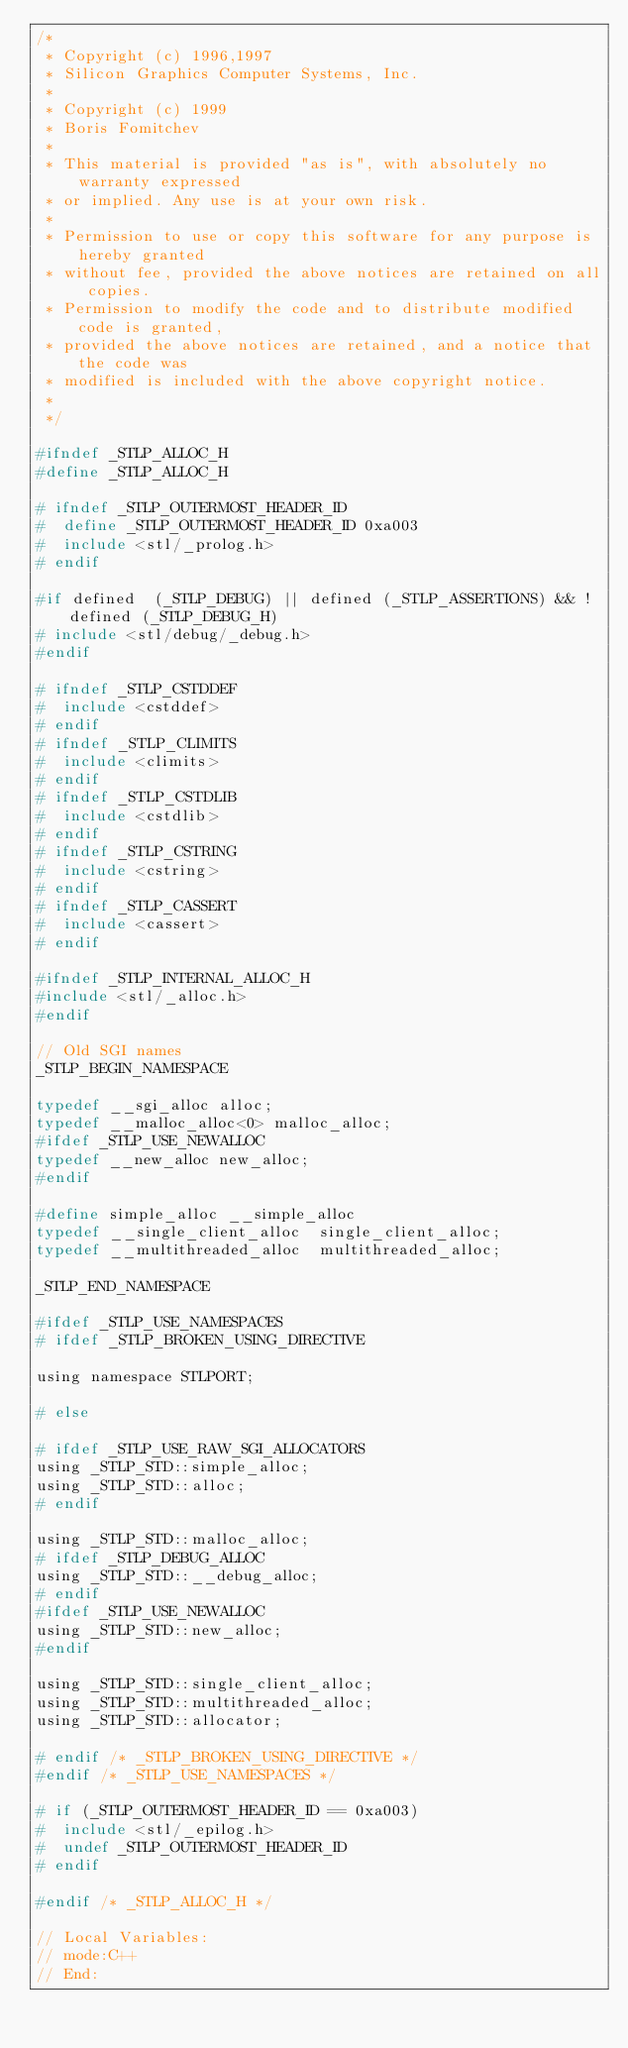<code> <loc_0><loc_0><loc_500><loc_500><_C_>/*
 * Copyright (c) 1996,1997
 * Silicon Graphics Computer Systems, Inc.
 *
 * Copyright (c) 1999 
 * Boris Fomitchev
 *
 * This material is provided "as is", with absolutely no warranty expressed
 * or implied. Any use is at your own risk.
 *
 * Permission to use or copy this software for any purpose is hereby granted 
 * without fee, provided the above notices are retained on all copies.
 * Permission to modify the code and to distribute modified code is granted,
 * provided the above notices are retained, and a notice that the code was
 * modified is included with the above copyright notice.
 *
 */

#ifndef _STLP_ALLOC_H
#define _STLP_ALLOC_H

# ifndef _STLP_OUTERMOST_HEADER_ID
#  define _STLP_OUTERMOST_HEADER_ID 0xa003
#  include <stl/_prolog.h>
# endif

#if defined  (_STLP_DEBUG) || defined (_STLP_ASSERTIONS) && !defined (_STLP_DEBUG_H)
# include <stl/debug/_debug.h>
#endif

# ifndef _STLP_CSTDDEF
#  include <cstddef>
# endif
# ifndef _STLP_CLIMITS
#  include <climits>
# endif
# ifndef _STLP_CSTDLIB
#  include <cstdlib>
# endif
# ifndef _STLP_CSTRING
#  include <cstring>
# endif
# ifndef _STLP_CASSERT
#  include <cassert>
# endif

#ifndef _STLP_INTERNAL_ALLOC_H
#include <stl/_alloc.h>
#endif

// Old SGI names
_STLP_BEGIN_NAMESPACE

typedef __sgi_alloc alloc;
typedef __malloc_alloc<0> malloc_alloc;
#ifdef _STLP_USE_NEWALLOC
typedef __new_alloc new_alloc;
#endif

#define simple_alloc __simple_alloc
typedef __single_client_alloc  single_client_alloc; 
typedef __multithreaded_alloc  multithreaded_alloc; 

_STLP_END_NAMESPACE

#ifdef _STLP_USE_NAMESPACES
# ifdef _STLP_BROKEN_USING_DIRECTIVE

using namespace STLPORT;

# else

# ifdef _STLP_USE_RAW_SGI_ALLOCATORS
using _STLP_STD::simple_alloc;
using _STLP_STD::alloc;
# endif

using _STLP_STD::malloc_alloc; 
# ifdef _STLP_DEBUG_ALLOC
using _STLP_STD::__debug_alloc;
# endif 
#ifdef _STLP_USE_NEWALLOC
using _STLP_STD::new_alloc;
#endif

using _STLP_STD::single_client_alloc; 
using _STLP_STD::multithreaded_alloc; 
using _STLP_STD::allocator;

# endif /* _STLP_BROKEN_USING_DIRECTIVE */
#endif /* _STLP_USE_NAMESPACES */

# if (_STLP_OUTERMOST_HEADER_ID == 0xa003)
#  include <stl/_epilog.h>
#  undef _STLP_OUTERMOST_HEADER_ID
# endif

#endif /* _STLP_ALLOC_H */

// Local Variables:
// mode:C++
// End:

</code> 